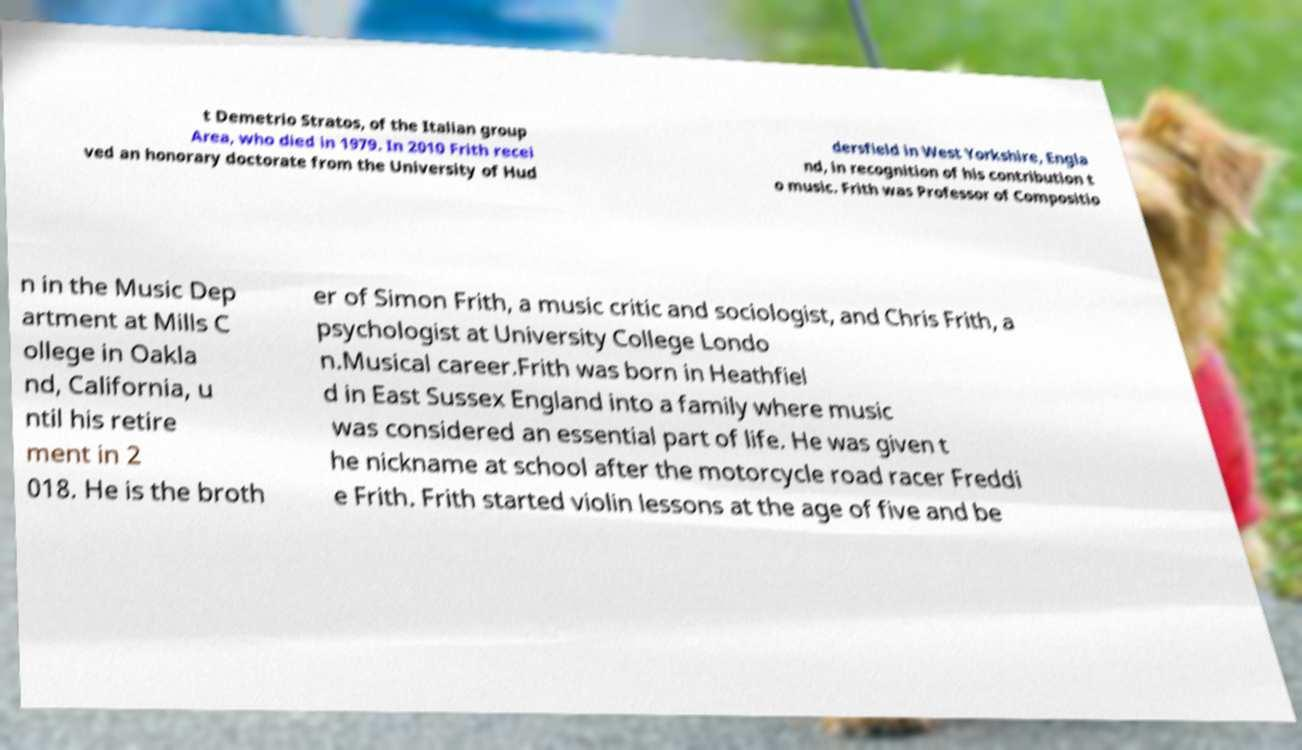Can you read and provide the text displayed in the image?This photo seems to have some interesting text. Can you extract and type it out for me? t Demetrio Stratos, of the Italian group Area, who died in 1979. In 2010 Frith recei ved an honorary doctorate from the University of Hud dersfield in West Yorkshire, Engla nd, in recognition of his contribution t o music. Frith was Professor of Compositio n in the Music Dep artment at Mills C ollege in Oakla nd, California, u ntil his retire ment in 2 018. He is the broth er of Simon Frith, a music critic and sociologist, and Chris Frith, a psychologist at University College Londo n.Musical career.Frith was born in Heathfiel d in East Sussex England into a family where music was considered an essential part of life. He was given t he nickname at school after the motorcycle road racer Freddi e Frith. Frith started violin lessons at the age of five and be 